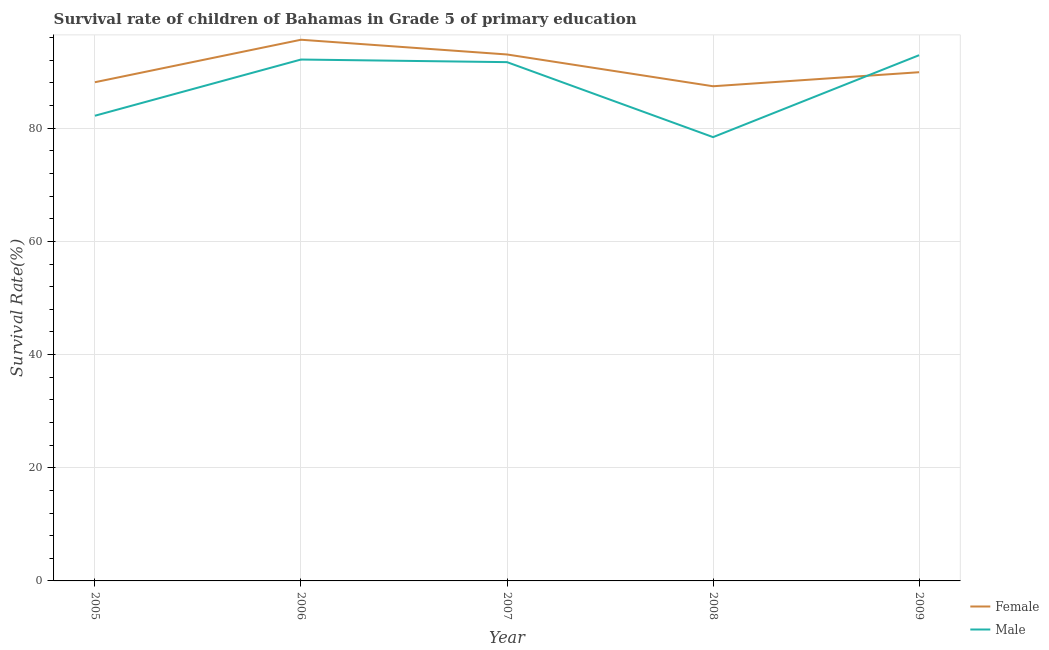Does the line corresponding to survival rate of male students in primary education intersect with the line corresponding to survival rate of female students in primary education?
Your answer should be compact. Yes. What is the survival rate of male students in primary education in 2008?
Keep it short and to the point. 78.43. Across all years, what is the maximum survival rate of female students in primary education?
Provide a succinct answer. 95.64. Across all years, what is the minimum survival rate of female students in primary education?
Offer a terse response. 87.42. In which year was the survival rate of male students in primary education maximum?
Your answer should be compact. 2009. In which year was the survival rate of female students in primary education minimum?
Your answer should be very brief. 2008. What is the total survival rate of female students in primary education in the graph?
Provide a short and direct response. 454.12. What is the difference between the survival rate of female students in primary education in 2005 and that in 2008?
Your answer should be compact. 0.71. What is the difference between the survival rate of male students in primary education in 2009 and the survival rate of female students in primary education in 2006?
Your answer should be compact. -2.73. What is the average survival rate of female students in primary education per year?
Offer a very short reply. 90.82. In the year 2008, what is the difference between the survival rate of female students in primary education and survival rate of male students in primary education?
Make the answer very short. 8.99. What is the ratio of the survival rate of male students in primary education in 2005 to that in 2008?
Offer a terse response. 1.05. Is the survival rate of female students in primary education in 2006 less than that in 2008?
Make the answer very short. No. Is the difference between the survival rate of female students in primary education in 2007 and 2009 greater than the difference between the survival rate of male students in primary education in 2007 and 2009?
Offer a terse response. Yes. What is the difference between the highest and the second highest survival rate of male students in primary education?
Offer a terse response. 0.77. What is the difference between the highest and the lowest survival rate of female students in primary education?
Make the answer very short. 8.22. In how many years, is the survival rate of female students in primary education greater than the average survival rate of female students in primary education taken over all years?
Provide a succinct answer. 2. Does the survival rate of male students in primary education monotonically increase over the years?
Provide a short and direct response. No. Is the survival rate of female students in primary education strictly greater than the survival rate of male students in primary education over the years?
Offer a very short reply. No. Is the survival rate of male students in primary education strictly less than the survival rate of female students in primary education over the years?
Make the answer very short. No. How many years are there in the graph?
Your response must be concise. 5. Are the values on the major ticks of Y-axis written in scientific E-notation?
Ensure brevity in your answer.  No. Does the graph contain grids?
Provide a short and direct response. Yes. Where does the legend appear in the graph?
Your answer should be compact. Bottom right. How many legend labels are there?
Ensure brevity in your answer.  2. How are the legend labels stacked?
Your answer should be very brief. Vertical. What is the title of the graph?
Keep it short and to the point. Survival rate of children of Bahamas in Grade 5 of primary education. What is the label or title of the Y-axis?
Provide a short and direct response. Survival Rate(%). What is the Survival Rate(%) of Female in 2005?
Keep it short and to the point. 88.13. What is the Survival Rate(%) of Male in 2005?
Provide a succinct answer. 82.21. What is the Survival Rate(%) in Female in 2006?
Your answer should be compact. 95.64. What is the Survival Rate(%) of Male in 2006?
Your response must be concise. 92.14. What is the Survival Rate(%) of Female in 2007?
Keep it short and to the point. 93.03. What is the Survival Rate(%) in Male in 2007?
Offer a terse response. 91.68. What is the Survival Rate(%) in Female in 2008?
Give a very brief answer. 87.42. What is the Survival Rate(%) in Male in 2008?
Make the answer very short. 78.43. What is the Survival Rate(%) in Female in 2009?
Make the answer very short. 89.9. What is the Survival Rate(%) in Male in 2009?
Provide a succinct answer. 92.91. Across all years, what is the maximum Survival Rate(%) in Female?
Your answer should be compact. 95.64. Across all years, what is the maximum Survival Rate(%) in Male?
Provide a short and direct response. 92.91. Across all years, what is the minimum Survival Rate(%) of Female?
Your response must be concise. 87.42. Across all years, what is the minimum Survival Rate(%) in Male?
Provide a short and direct response. 78.43. What is the total Survival Rate(%) in Female in the graph?
Provide a succinct answer. 454.12. What is the total Survival Rate(%) in Male in the graph?
Provide a succinct answer. 437.36. What is the difference between the Survival Rate(%) of Female in 2005 and that in 2006?
Make the answer very short. -7.51. What is the difference between the Survival Rate(%) of Male in 2005 and that in 2006?
Provide a short and direct response. -9.93. What is the difference between the Survival Rate(%) of Female in 2005 and that in 2007?
Keep it short and to the point. -4.9. What is the difference between the Survival Rate(%) of Male in 2005 and that in 2007?
Give a very brief answer. -9.47. What is the difference between the Survival Rate(%) of Female in 2005 and that in 2008?
Offer a very short reply. 0.71. What is the difference between the Survival Rate(%) of Male in 2005 and that in 2008?
Ensure brevity in your answer.  3.78. What is the difference between the Survival Rate(%) of Female in 2005 and that in 2009?
Your response must be concise. -1.77. What is the difference between the Survival Rate(%) of Male in 2005 and that in 2009?
Your answer should be very brief. -10.7. What is the difference between the Survival Rate(%) in Female in 2006 and that in 2007?
Provide a short and direct response. 2.6. What is the difference between the Survival Rate(%) of Male in 2006 and that in 2007?
Keep it short and to the point. 0.46. What is the difference between the Survival Rate(%) in Female in 2006 and that in 2008?
Offer a very short reply. 8.22. What is the difference between the Survival Rate(%) of Male in 2006 and that in 2008?
Your answer should be compact. 13.71. What is the difference between the Survival Rate(%) in Female in 2006 and that in 2009?
Keep it short and to the point. 5.74. What is the difference between the Survival Rate(%) in Male in 2006 and that in 2009?
Offer a terse response. -0.77. What is the difference between the Survival Rate(%) of Female in 2007 and that in 2008?
Ensure brevity in your answer.  5.62. What is the difference between the Survival Rate(%) in Male in 2007 and that in 2008?
Give a very brief answer. 13.25. What is the difference between the Survival Rate(%) in Female in 2007 and that in 2009?
Offer a very short reply. 3.14. What is the difference between the Survival Rate(%) in Male in 2007 and that in 2009?
Your answer should be very brief. -1.23. What is the difference between the Survival Rate(%) in Female in 2008 and that in 2009?
Offer a very short reply. -2.48. What is the difference between the Survival Rate(%) in Male in 2008 and that in 2009?
Your answer should be very brief. -14.48. What is the difference between the Survival Rate(%) in Female in 2005 and the Survival Rate(%) in Male in 2006?
Offer a very short reply. -4.01. What is the difference between the Survival Rate(%) of Female in 2005 and the Survival Rate(%) of Male in 2007?
Offer a very short reply. -3.55. What is the difference between the Survival Rate(%) of Female in 2005 and the Survival Rate(%) of Male in 2008?
Make the answer very short. 9.7. What is the difference between the Survival Rate(%) in Female in 2005 and the Survival Rate(%) in Male in 2009?
Offer a very short reply. -4.78. What is the difference between the Survival Rate(%) in Female in 2006 and the Survival Rate(%) in Male in 2007?
Provide a succinct answer. 3.96. What is the difference between the Survival Rate(%) of Female in 2006 and the Survival Rate(%) of Male in 2008?
Your response must be concise. 17.21. What is the difference between the Survival Rate(%) of Female in 2006 and the Survival Rate(%) of Male in 2009?
Make the answer very short. 2.73. What is the difference between the Survival Rate(%) in Female in 2007 and the Survival Rate(%) in Male in 2008?
Give a very brief answer. 14.61. What is the difference between the Survival Rate(%) of Female in 2007 and the Survival Rate(%) of Male in 2009?
Ensure brevity in your answer.  0.13. What is the difference between the Survival Rate(%) in Female in 2008 and the Survival Rate(%) in Male in 2009?
Your answer should be very brief. -5.49. What is the average Survival Rate(%) of Female per year?
Offer a terse response. 90.82. What is the average Survival Rate(%) of Male per year?
Your answer should be compact. 87.47. In the year 2005, what is the difference between the Survival Rate(%) in Female and Survival Rate(%) in Male?
Your response must be concise. 5.92. In the year 2006, what is the difference between the Survival Rate(%) in Female and Survival Rate(%) in Male?
Offer a terse response. 3.5. In the year 2007, what is the difference between the Survival Rate(%) in Female and Survival Rate(%) in Male?
Keep it short and to the point. 1.36. In the year 2008, what is the difference between the Survival Rate(%) in Female and Survival Rate(%) in Male?
Offer a terse response. 8.99. In the year 2009, what is the difference between the Survival Rate(%) in Female and Survival Rate(%) in Male?
Provide a succinct answer. -3.01. What is the ratio of the Survival Rate(%) of Female in 2005 to that in 2006?
Offer a terse response. 0.92. What is the ratio of the Survival Rate(%) of Male in 2005 to that in 2006?
Give a very brief answer. 0.89. What is the ratio of the Survival Rate(%) of Female in 2005 to that in 2007?
Your answer should be very brief. 0.95. What is the ratio of the Survival Rate(%) in Male in 2005 to that in 2007?
Your answer should be very brief. 0.9. What is the ratio of the Survival Rate(%) of Male in 2005 to that in 2008?
Your response must be concise. 1.05. What is the ratio of the Survival Rate(%) of Female in 2005 to that in 2009?
Make the answer very short. 0.98. What is the ratio of the Survival Rate(%) in Male in 2005 to that in 2009?
Give a very brief answer. 0.88. What is the ratio of the Survival Rate(%) of Female in 2006 to that in 2007?
Give a very brief answer. 1.03. What is the ratio of the Survival Rate(%) of Male in 2006 to that in 2007?
Ensure brevity in your answer.  1. What is the ratio of the Survival Rate(%) in Female in 2006 to that in 2008?
Your response must be concise. 1.09. What is the ratio of the Survival Rate(%) in Male in 2006 to that in 2008?
Make the answer very short. 1.17. What is the ratio of the Survival Rate(%) of Female in 2006 to that in 2009?
Provide a short and direct response. 1.06. What is the ratio of the Survival Rate(%) in Female in 2007 to that in 2008?
Your answer should be very brief. 1.06. What is the ratio of the Survival Rate(%) of Male in 2007 to that in 2008?
Your response must be concise. 1.17. What is the ratio of the Survival Rate(%) in Female in 2007 to that in 2009?
Offer a very short reply. 1.03. What is the ratio of the Survival Rate(%) in Female in 2008 to that in 2009?
Your answer should be compact. 0.97. What is the ratio of the Survival Rate(%) of Male in 2008 to that in 2009?
Your answer should be compact. 0.84. What is the difference between the highest and the second highest Survival Rate(%) in Female?
Ensure brevity in your answer.  2.6. What is the difference between the highest and the second highest Survival Rate(%) of Male?
Keep it short and to the point. 0.77. What is the difference between the highest and the lowest Survival Rate(%) of Female?
Make the answer very short. 8.22. What is the difference between the highest and the lowest Survival Rate(%) of Male?
Offer a terse response. 14.48. 